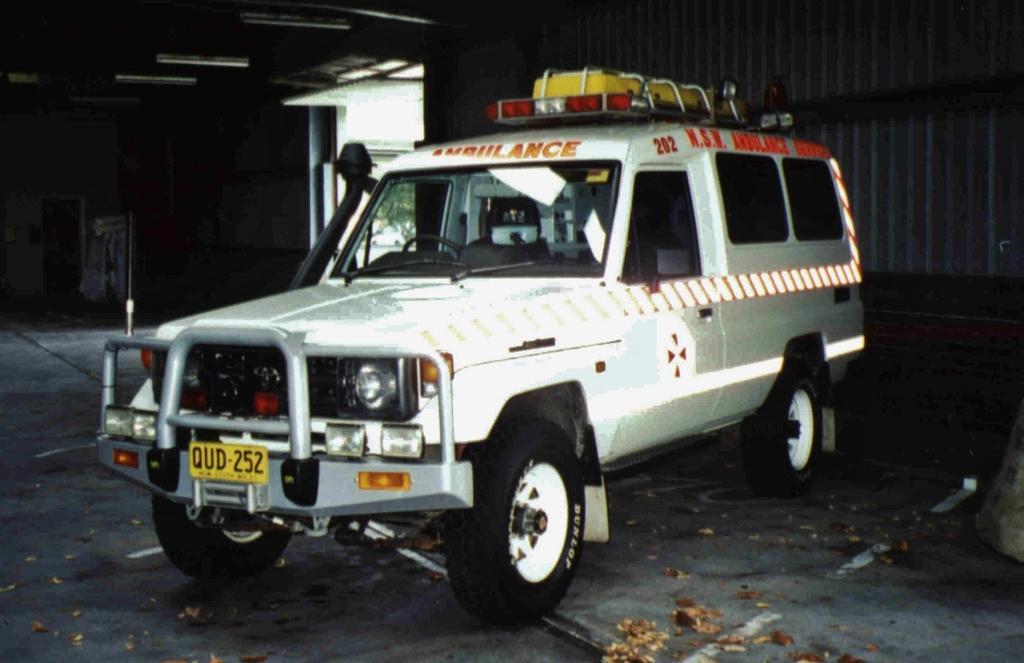In one or two sentences, can you explain what this image depicts? This is an inside view of a shed. In this picture we can see a vehicle and objects. In the background we can see metal panel and a tree is visible. 